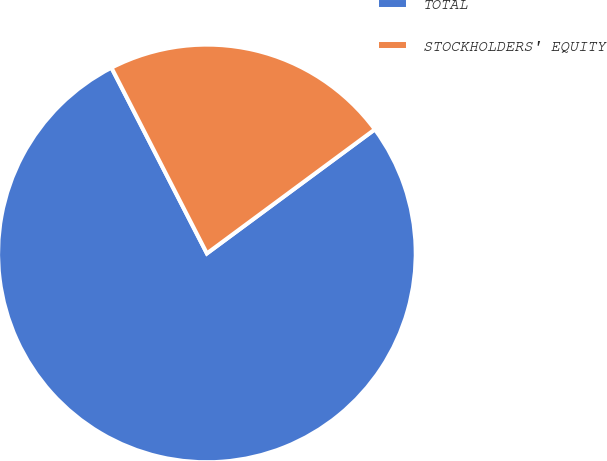Convert chart. <chart><loc_0><loc_0><loc_500><loc_500><pie_chart><fcel>TOTAL<fcel>STOCKHOLDERS' EQUITY<nl><fcel>77.57%<fcel>22.43%<nl></chart> 